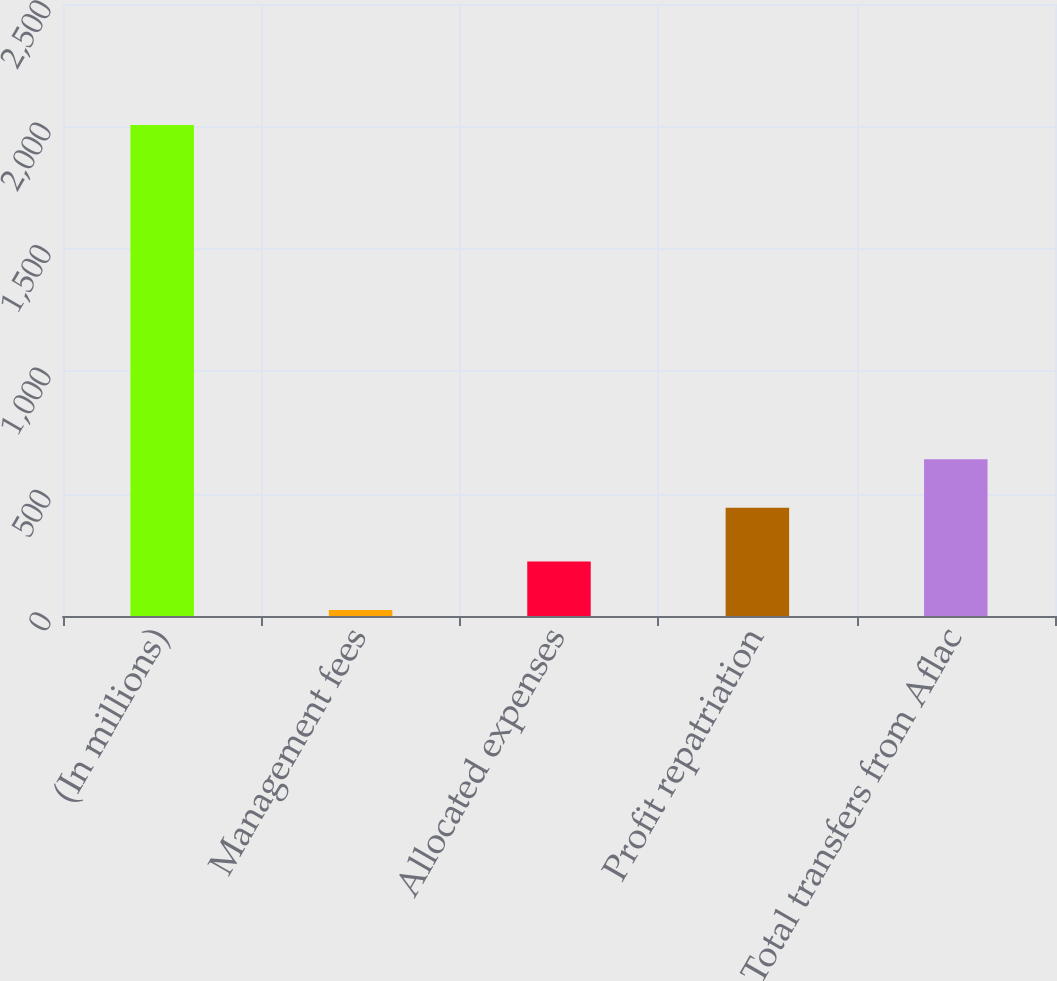Convert chart. <chart><loc_0><loc_0><loc_500><loc_500><bar_chart><fcel>(In millions)<fcel>Management fees<fcel>Allocated expenses<fcel>Profit repatriation<fcel>Total transfers from Aflac<nl><fcel>2006<fcel>25<fcel>223.1<fcel>442<fcel>640.1<nl></chart> 